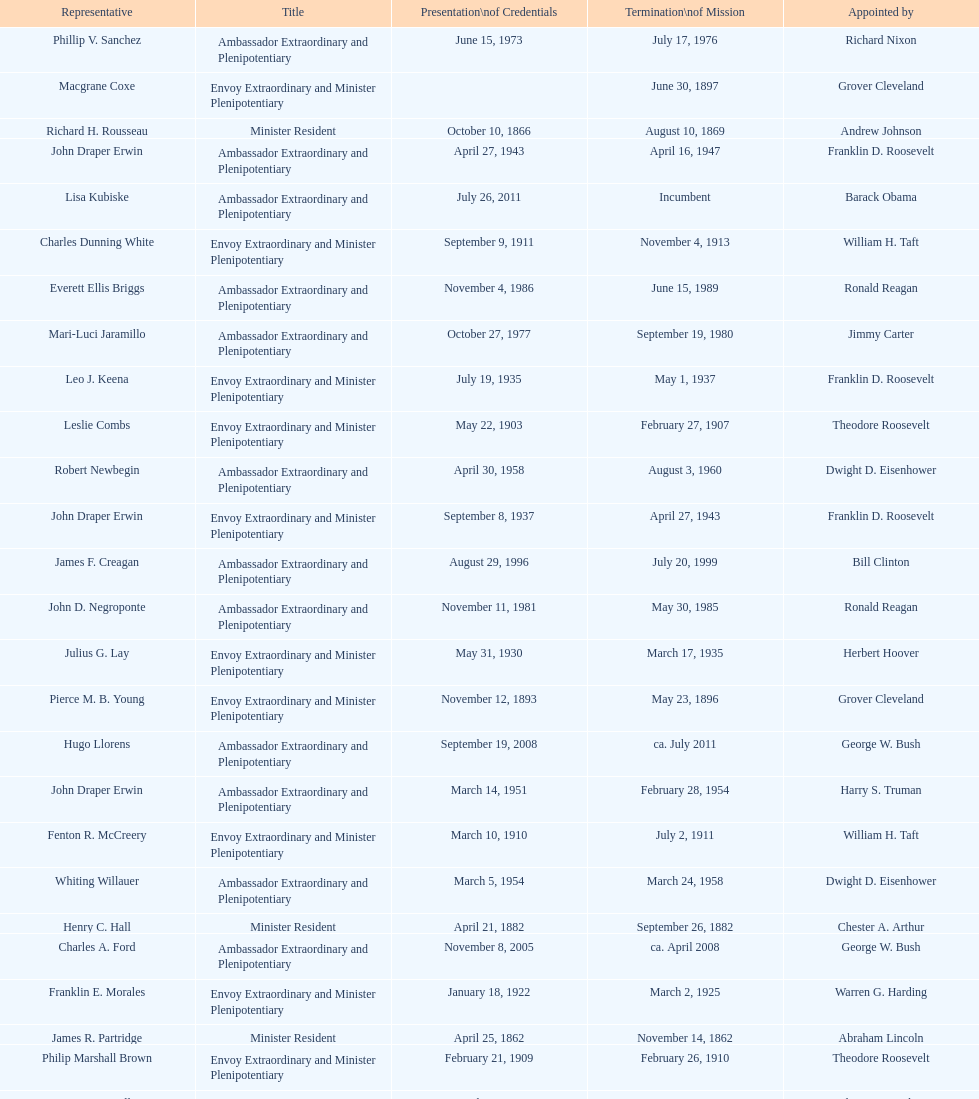Who is the only ambassadors to honduras appointed by barack obama? Lisa Kubiske. 